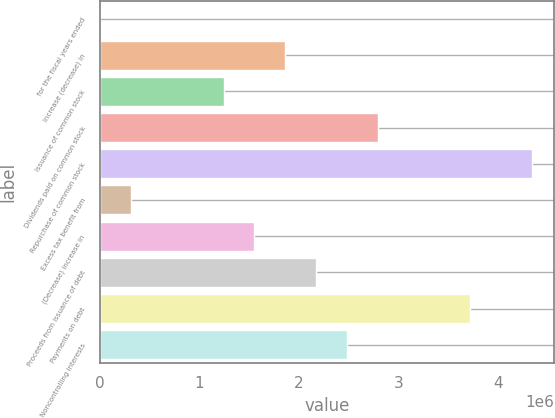Convert chart. <chart><loc_0><loc_0><loc_500><loc_500><bar_chart><fcel>for the fiscal years ended<fcel>Increase (decrease) in<fcel>Issuance of common stock<fcel>Dividends paid on common stock<fcel>Repurchase of common stock<fcel>Excess tax benefit from<fcel>(Decrease) increase in<fcel>Proceeds from issuance of debt<fcel>Payments on debt<fcel>Noncontrolling interests<nl><fcel>2009<fcel>1.86347e+06<fcel>1.24299e+06<fcel>2.79421e+06<fcel>4.34543e+06<fcel>312253<fcel>1.55323e+06<fcel>2.17372e+06<fcel>3.72494e+06<fcel>2.48396e+06<nl></chart> 